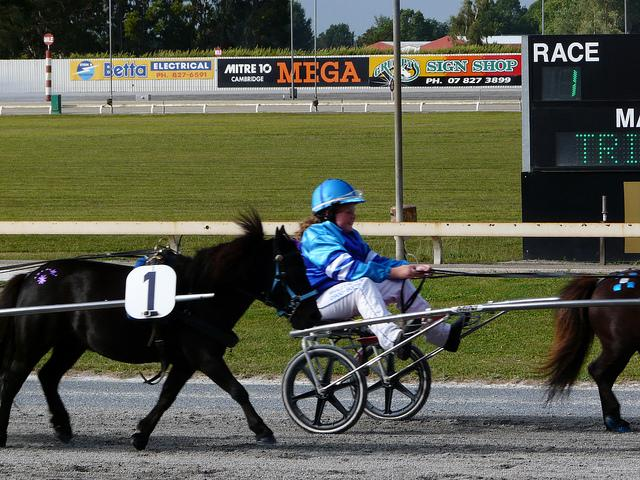What is this activity? harness racing 